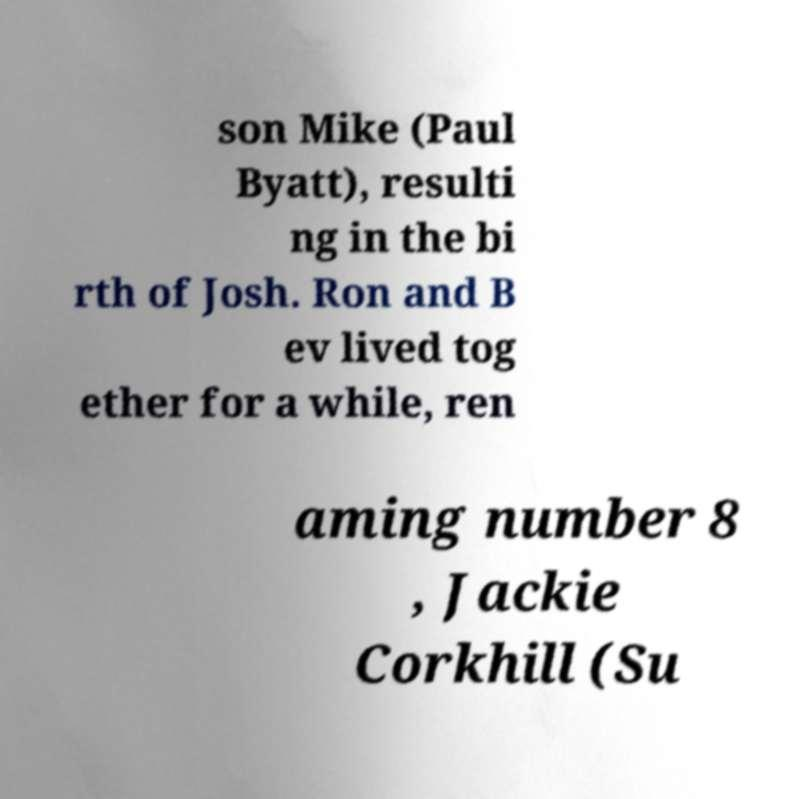What messages or text are displayed in this image? I need them in a readable, typed format. son Mike (Paul Byatt), resulti ng in the bi rth of Josh. Ron and B ev lived tog ether for a while, ren aming number 8 , Jackie Corkhill (Su 